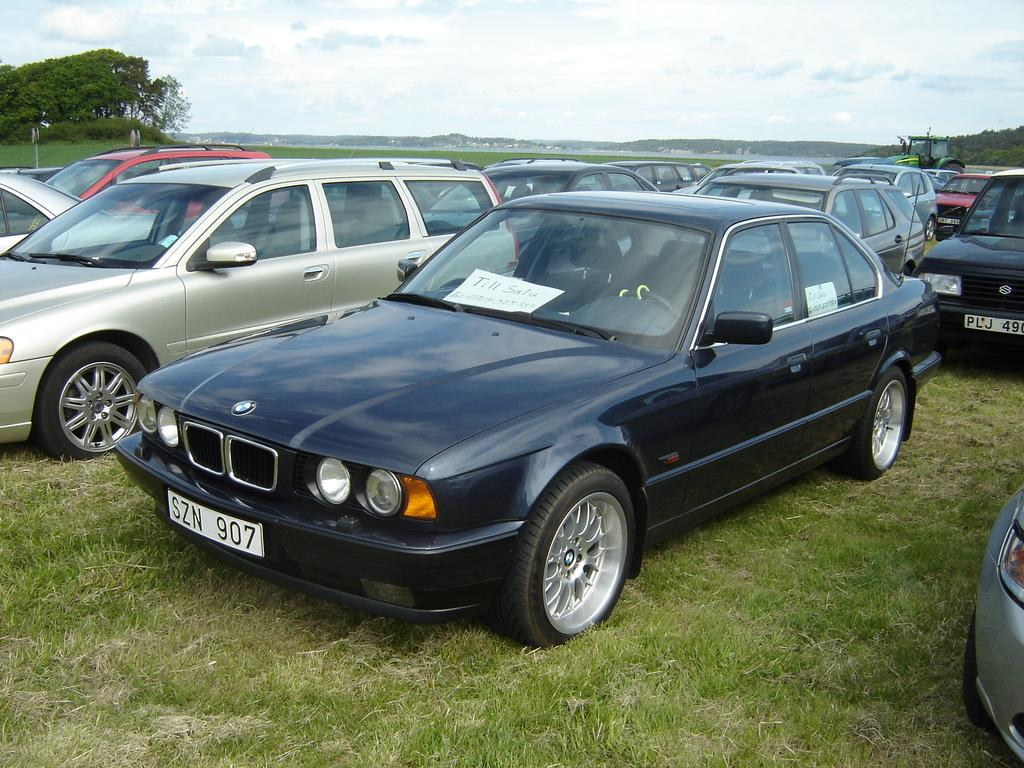What type of vehicles can be seen in the image? There are cars in the image. What is the surface on which the cars are located? There is grass on the surface in the image. What can be seen in the background of the image? There are trees, mountains, buildings, and the sky visible in the background of the image. What type of furniture is being crushed by the cars in the image? There is no furniture present in the image, and the cars are not crushing anything. 